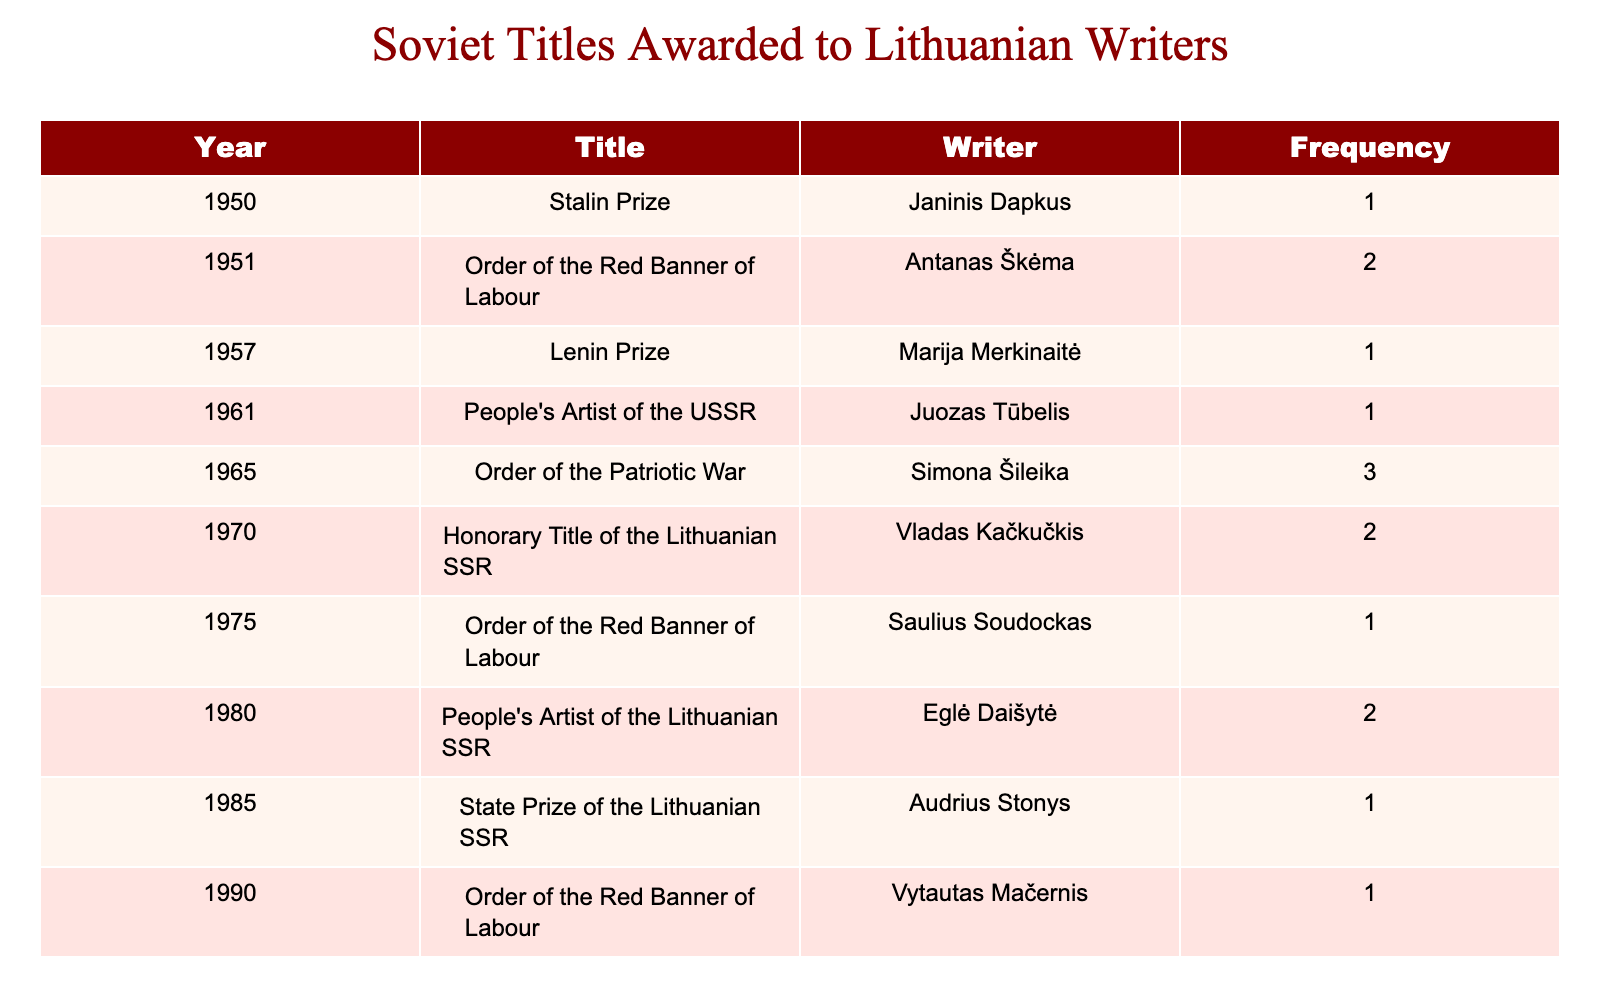What year was the Order of the Red Banner of Labour awarded to the most writers? The table shows that the Order of the Red Banner of Labour was awarded in three different years: 1951 with 2 awards, 1975 with 1 award, and 1990 with 1 award. The maximum frequency of this title awarded is 2, in the year 1951.
Answer: 1951 Which writer received the Lenin Prize? The table lists Marija Merkinaitė as the only writer who received the Lenin Prize in 1957, with a frequency of 1.
Answer: Marija Merkinaitė Is there any writer who has received the Honorary Title of the Lithuanian SSR? Yes, Vladas Kačkučkis is noted as receiving the Honorary Title of the Lithuanian SSR in the year 1970, with a frequency of 2.
Answer: Yes What is the total frequency of titles awarded in the 1980s? The table indicates that the titles awarded during the 1980s are from 1980 (2) and 1985 (1). Adding these frequencies together results in 2 + 1 = 3.
Answer: 3 Which Soviet title was awarded to Juozas Tūbelis and in what year? Juozas Tūbelis received the title of People's Artist of the USSR in the year 1961, with a frequency of 1.
Answer: People's Artist of the USSR in 1961 How many different titles were awarded to Lithuanian writers before 1970? The titles awarded before 1970 were: Stalin Prize (1950), Order of the Red Banner of Labour (1951), Lenin Prize (1957), People's Artist of the USSR (1961), and Order of the Patriotic War (1965). This totals 5 different titles.
Answer: 5 What is the average frequency of awards received by writers across all titles listed? First, sum the frequencies: 1 + 2 + 1 + 1 + 3 + 2 + 1 + 2 + 1 = 14. There are 9 entries in total, so the average frequency is 14/9, which is approximately 1.56 when rounded to two decimal places.
Answer: 1.56 Did anyone receive the State Prize of the Lithuanian SSR more than once? No, the table shows that Audrius Stonys received the State Prize of the Lithuanian SSR only once in 1985. Thus, there are no writers who received this title more than once.
Answer: No How many writers received the Order of the Red Banner of Labour in total? The table shows that the Order of the Red Banner of Labour was awarded to three different writers: Antanas Škėma in 1951 (2 times), Saulius Soudockas in 1975 (1 time), and Vytautas Mačernis in 1990 (1 time). Therefore, the total number of unique writers is 3.
Answer: 3 